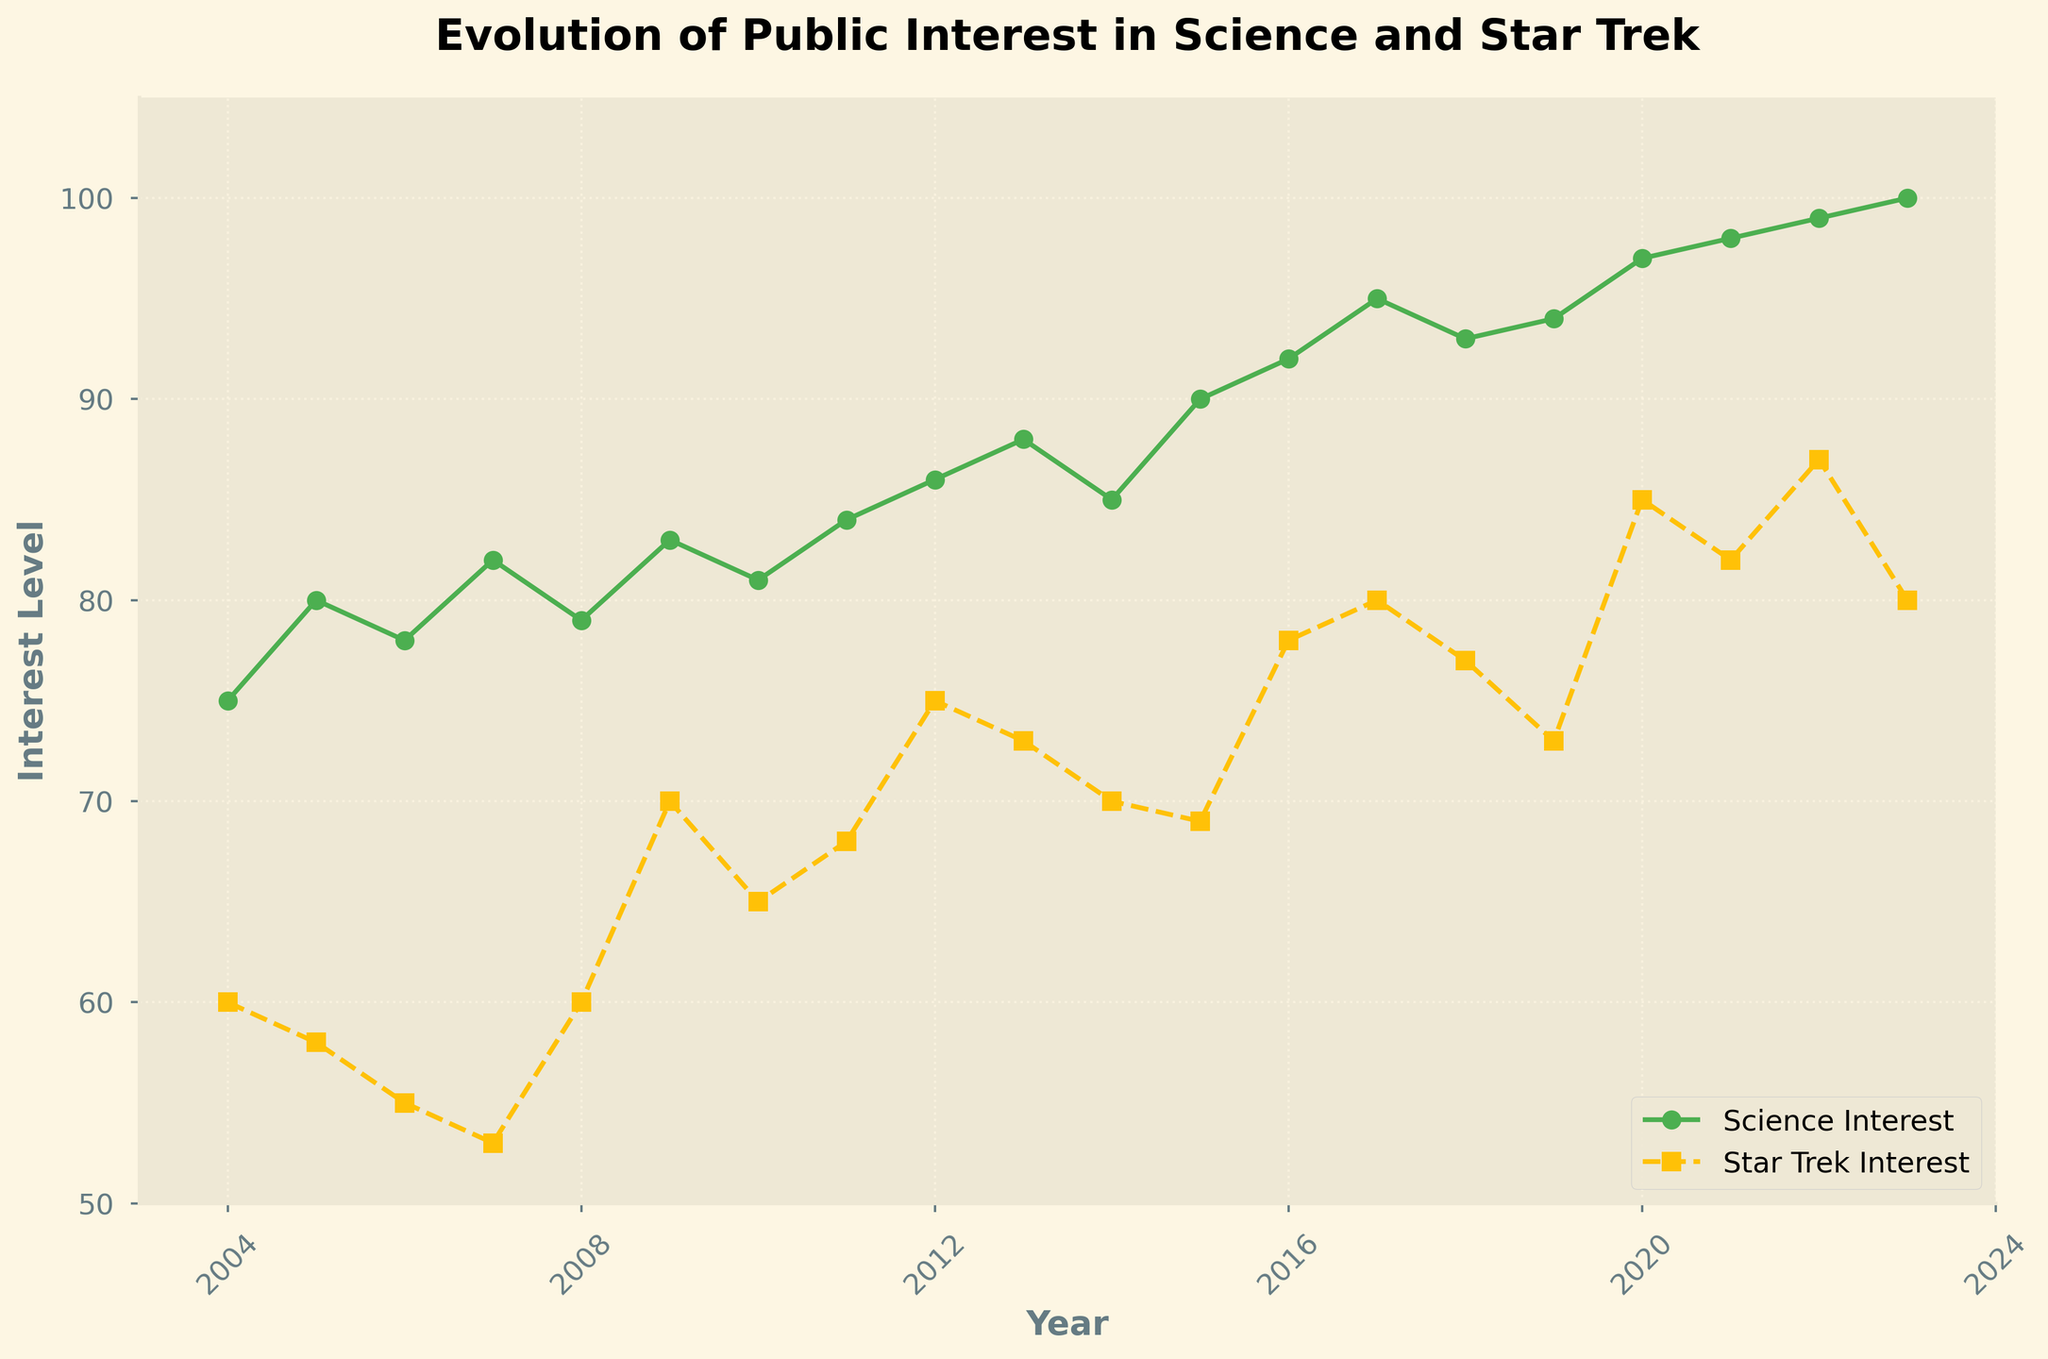What is the title of the figure? The title of the figure is displayed at the top of the chart. It is meant to describe the content of the chart in a concise manner.
Answer: Evolution of Public Interest in Science and Star Trek How many interest data points are plotted for Science? There is one data point for each year from 2004 to 2023. By counting these points, we can determine the total number of data points for Science.
Answer: 20 What is the interest level in science in 2020? The interest level in science in 2020 can be found by locating the data point corresponding to 2020 on the Science Interest line.
Answer: 97 Which year had the highest public interest in Star Trek? To find this, we look for the highest data point on the Star Trek Interest line. The x-axis value corresponding to this point indicates the year.
Answer: 2022 How did the public interest in Star Trek change between 2009 and 2016? To answer this, subtract the interest level in 2009 from the level in 2016.
Answer: Increased by 8 What is the difference in interest levels between Science and Star Trek in 2017? Locate both interest levels for 2017 on their respective lines, then subtract the Star Trek interest from the Science interest.
Answer: 15 Which subject had a greater increase in public interest from 2011 to 2021? Calculate the change for both subjects by subtracting the 2011 interest levels from the 2021 levels, and compare these values.
Answer: Science Was the public interest in Star Trek ever higher than Science during the period shown? Look for any points where the Star Trek Interest line is above the Science Interest line.
Answer: No Calculate the average public interest in science over the entire period. Sum all the data points for Science and divide by the number of years (20).
Answer: 88.75 How did the public interest in science progress from 2004 to 2023? Examine the overall trend by observing the increase or decrease trajectory of the Science Interest line over the years.
Answer: It generally increased steadily 